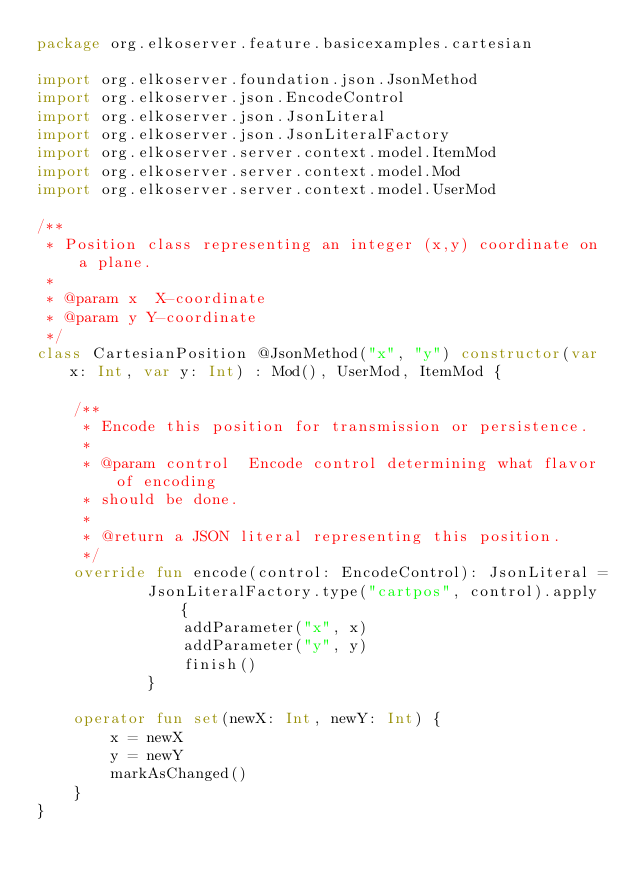Convert code to text. <code><loc_0><loc_0><loc_500><loc_500><_Kotlin_>package org.elkoserver.feature.basicexamples.cartesian

import org.elkoserver.foundation.json.JsonMethod
import org.elkoserver.json.EncodeControl
import org.elkoserver.json.JsonLiteral
import org.elkoserver.json.JsonLiteralFactory
import org.elkoserver.server.context.model.ItemMod
import org.elkoserver.server.context.model.Mod
import org.elkoserver.server.context.model.UserMod

/**
 * Position class representing an integer (x,y) coordinate on a plane.
 *
 * @param x  X-coordinate
 * @param y Y-coordinate
 */
class CartesianPosition @JsonMethod("x", "y") constructor(var x: Int, var y: Int) : Mod(), UserMod, ItemMod {

    /**
     * Encode this position for transmission or persistence.
     *
     * @param control  Encode control determining what flavor of encoding
     * should be done.
     *
     * @return a JSON literal representing this position.
     */
    override fun encode(control: EncodeControl): JsonLiteral =
            JsonLiteralFactory.type("cartpos", control).apply {
                addParameter("x", x)
                addParameter("y", y)
                finish()
            }

    operator fun set(newX: Int, newY: Int) {
        x = newX
        y = newY
        markAsChanged()
    }
}
</code> 